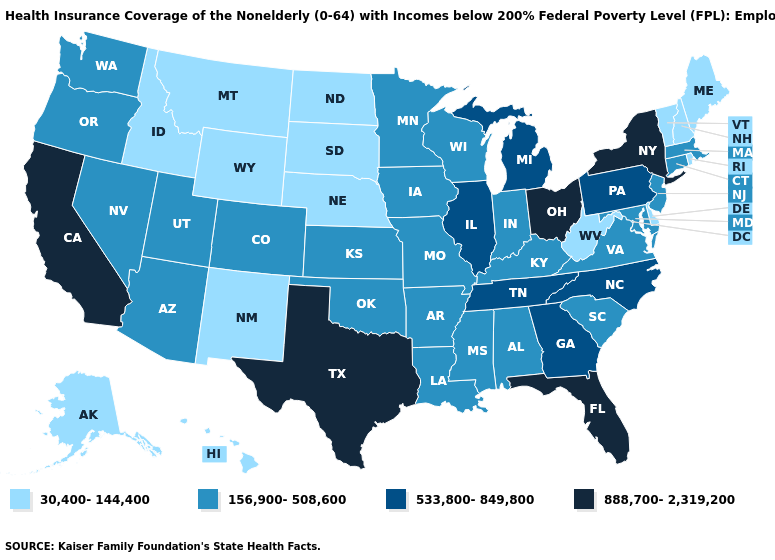Does the first symbol in the legend represent the smallest category?
Concise answer only. Yes. Is the legend a continuous bar?
Be succinct. No. Does Washington have the same value as New Hampshire?
Keep it brief. No. What is the value of Louisiana?
Quick response, please. 156,900-508,600. Which states have the lowest value in the USA?
Quick response, please. Alaska, Delaware, Hawaii, Idaho, Maine, Montana, Nebraska, New Hampshire, New Mexico, North Dakota, Rhode Island, South Dakota, Vermont, West Virginia, Wyoming. What is the lowest value in the USA?
Keep it brief. 30,400-144,400. Name the states that have a value in the range 30,400-144,400?
Keep it brief. Alaska, Delaware, Hawaii, Idaho, Maine, Montana, Nebraska, New Hampshire, New Mexico, North Dakota, Rhode Island, South Dakota, Vermont, West Virginia, Wyoming. Name the states that have a value in the range 533,800-849,800?
Short answer required. Georgia, Illinois, Michigan, North Carolina, Pennsylvania, Tennessee. Name the states that have a value in the range 888,700-2,319,200?
Answer briefly. California, Florida, New York, Ohio, Texas. Name the states that have a value in the range 888,700-2,319,200?
Quick response, please. California, Florida, New York, Ohio, Texas. Name the states that have a value in the range 533,800-849,800?
Short answer required. Georgia, Illinois, Michigan, North Carolina, Pennsylvania, Tennessee. Does Connecticut have the highest value in the USA?
Short answer required. No. What is the value of California?
Write a very short answer. 888,700-2,319,200. Does the map have missing data?
Concise answer only. No. Name the states that have a value in the range 533,800-849,800?
Concise answer only. Georgia, Illinois, Michigan, North Carolina, Pennsylvania, Tennessee. 